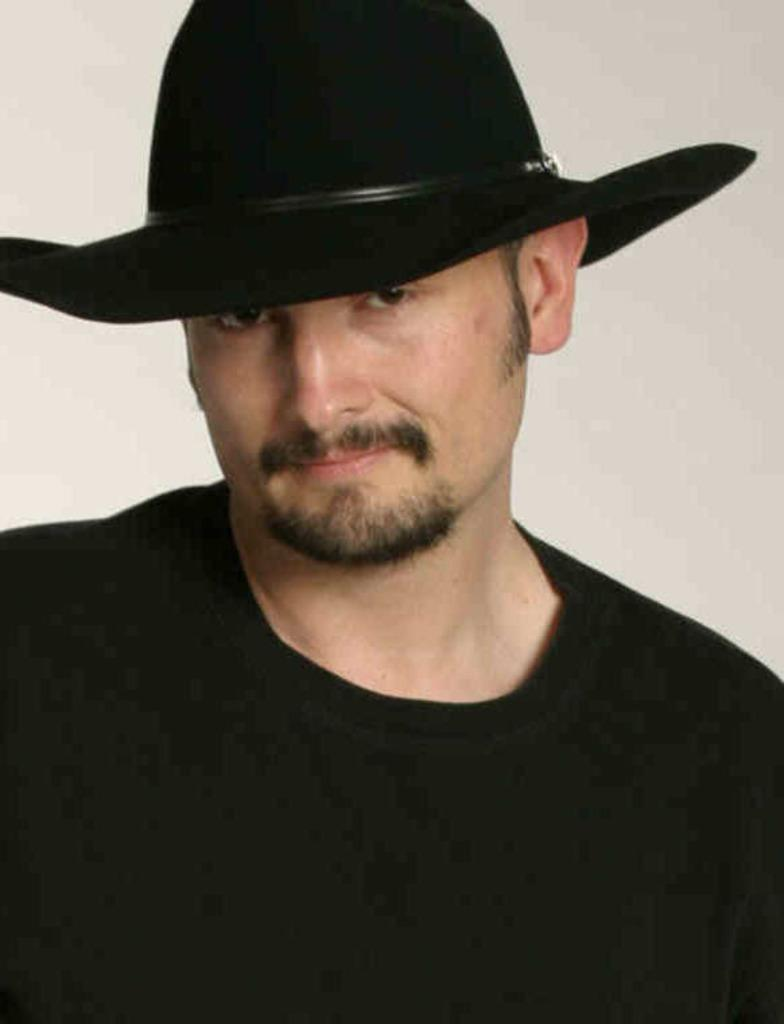What is the color of the background in the image? The background of the image is gray in color. Who or what is the main subject in the image? There is a man in the middle of the image. What is the man wearing on his upper body? The man is wearing a T-shirt. What type of headwear is the man wearing? The man is wearing a hat. What type of punishment is the man receiving in the image? There is no indication of punishment in the image; it simply shows a man wearing a T-shirt and a hat. What kind of paper can be seen in the man's hand in the image? There is no paper visible in the man's hand in the image. 